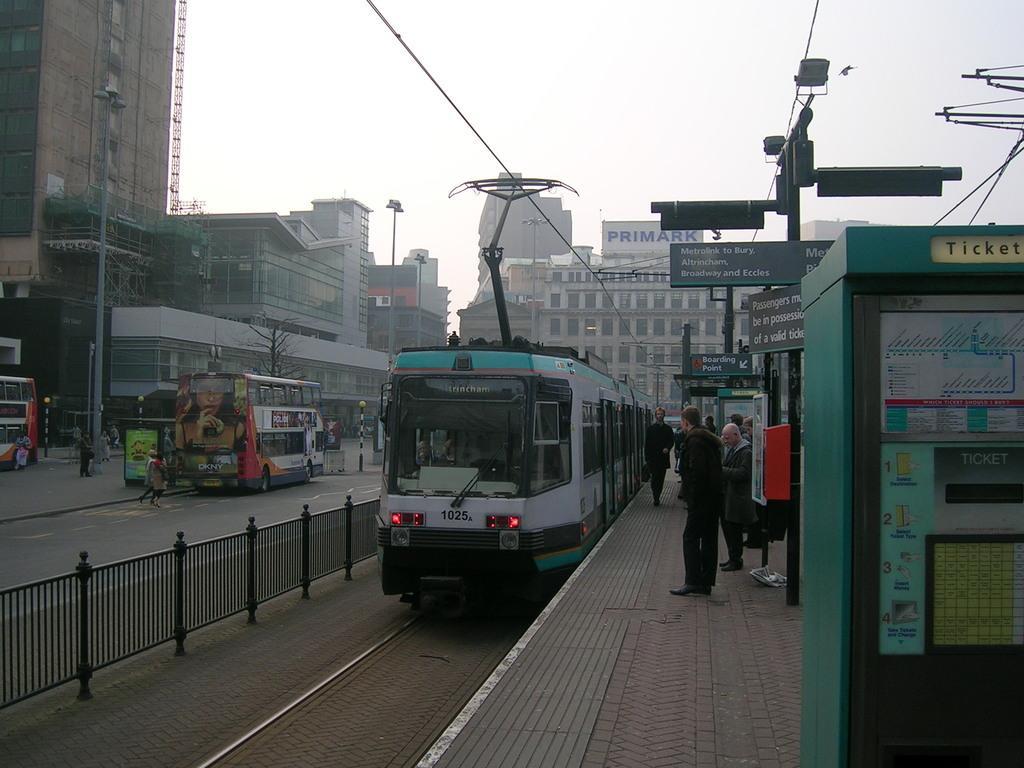In one or two sentences, can you explain what this image depicts? In this image, this looks like a tram, which is on the tramway track. I can see few people standing on the platform. This looks like a double-decker bus, which is on the road. These are the buildings with the glass doors and windows. I think this is a hoarding. These are the boards attached to the poles. This looks like a ticket machine. I can see few people walking. These are the kind of barricades. I think these are the street lights. This looks like a tree. 